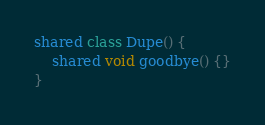<code> <loc_0><loc_0><loc_500><loc_500><_Ceylon_>shared class Dupe() {
    shared void goodbye() {}
}</code> 